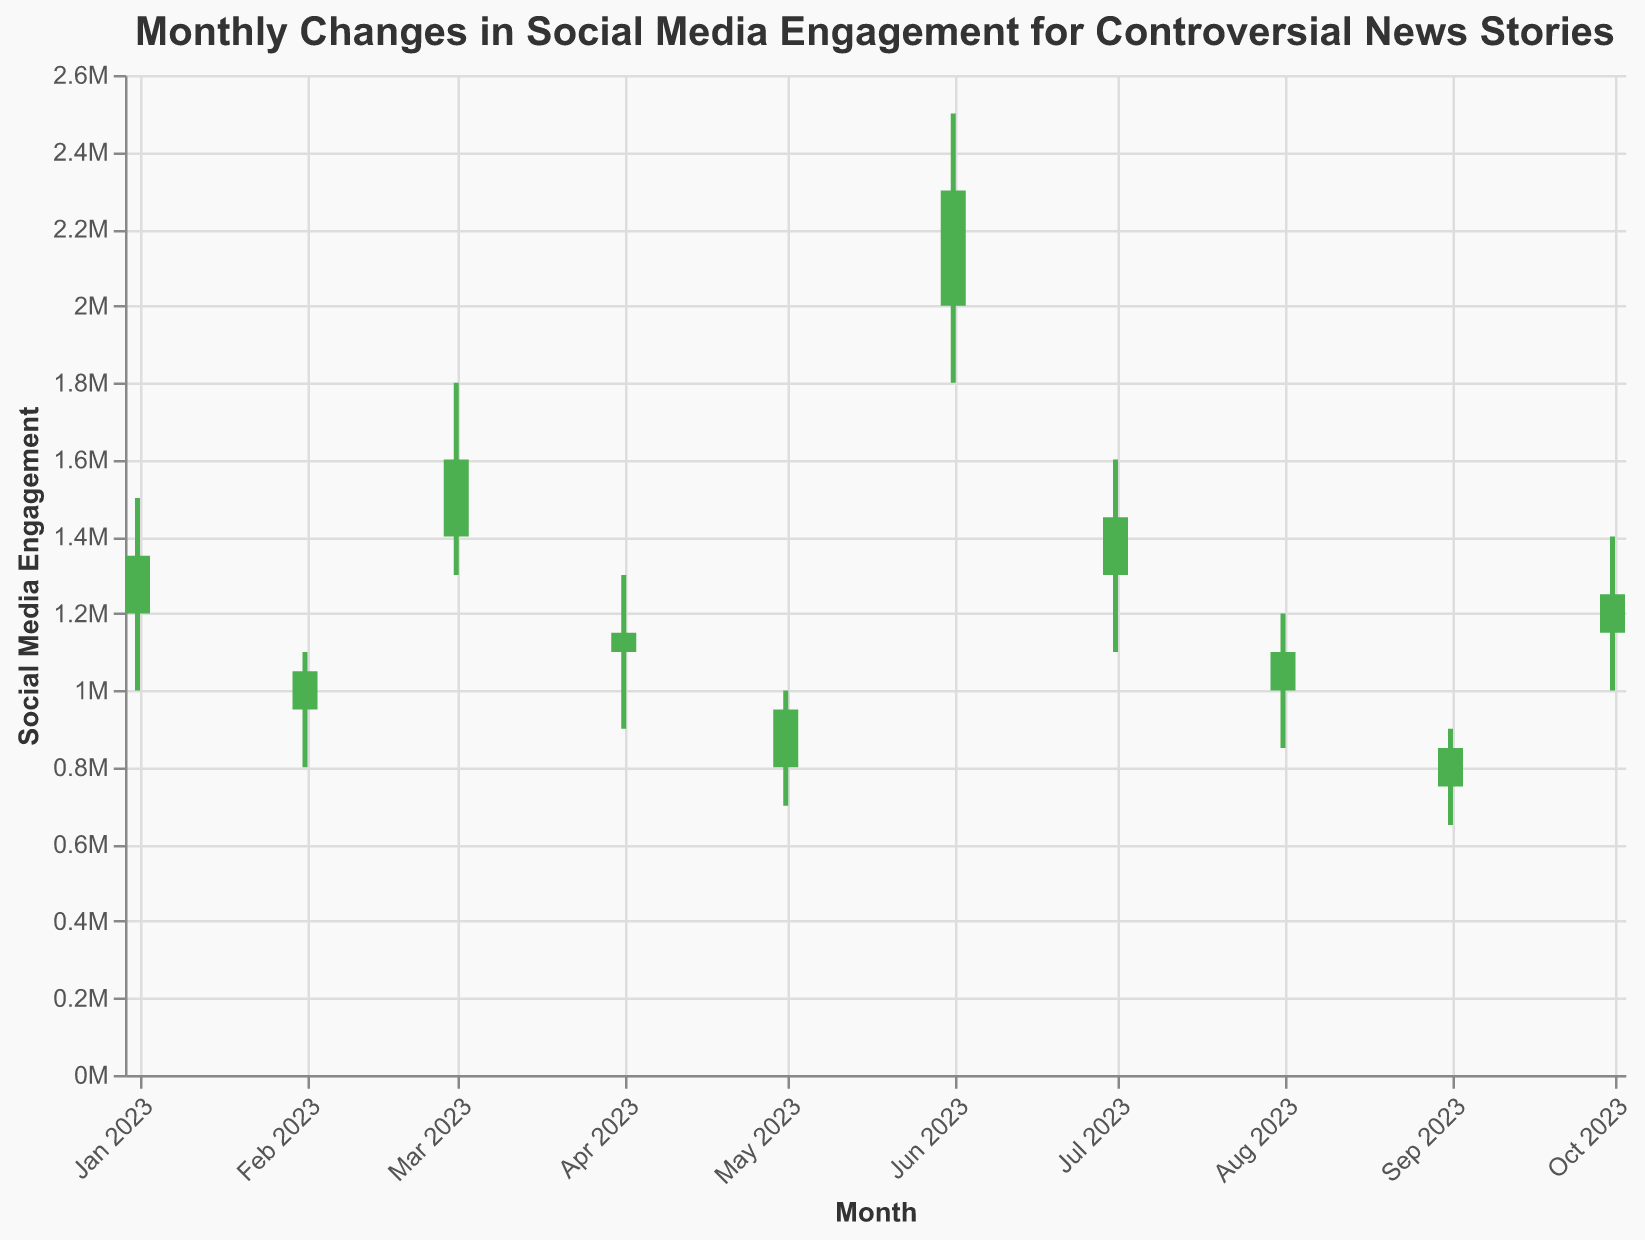Which story had the highest peak social media engagement? The highest peak social media engagement can be determined by looking at the "High" values for each story. The "Trump Indictment" in June has the highest peak at 2,500,000.
Answer: Trump Indictment Which month experienced the most significant drop in engagement from high to low? The most significant drop from high to low is calculated by finding the difference between the "High" and "Low" values for each month. The "Trump Indictment" in June shows the largest drop, from 2,500,000 to 1,800,000, a difference of 700,000.
Answer: June How did the engagement for "Critical Race Theory" change throughout May? The change in engagement for "Critical Race Theory" can be determined by comparing the "Open" and "Close" values. The engagement opened at 800,000 and closed at 950,000, indicating an increase of 150,000.
Answer: Increased by 150,000 Which story had the smallest range of engagement? The smallest range of engagement is calculated by finding the difference between the "High" and "Low" values for each story. The "Climate Change Debate" in February has a range of 300,000 (1,100,000 - 800,000).
Answer: Climate Change Debate Did engagement for "Election Integrity" increase or decrease in April? The change in engagement for "Election Integrity" is determined by comparing the "Open" and "Close" values. The engagement opened at 1,100,000 and closed at 1,150,000, indicating an increase.
Answer: Increased What was the social media engagement for "Hunter Biden Laptop" by the end of January? The social media engagement by the end of January is indicated by the "Close" value, which is 1,350,000 for "Hunter Biden Laptop".
Answer: 1,350,000 Which two stories had similar closing engagements, and what were those values? By comparing the "Close" values, "Climate Change Debate" in February and "Big Tech Censorship" in August both had a closing engagement of 1,100,000.
Answer: Climate Change Debate and Big Tech Censorship, 1,100,000 How did the engagement for "COVID-19 Origin" evolve in March? The engagement evolution for "COVID-19 Origin" can be observed by comparing "Open" and "Close" values. In March, it opened at 1,400,000 and closed at 1,600,000, indicating an increase of 200,000.
Answer: Increased by 200,000 